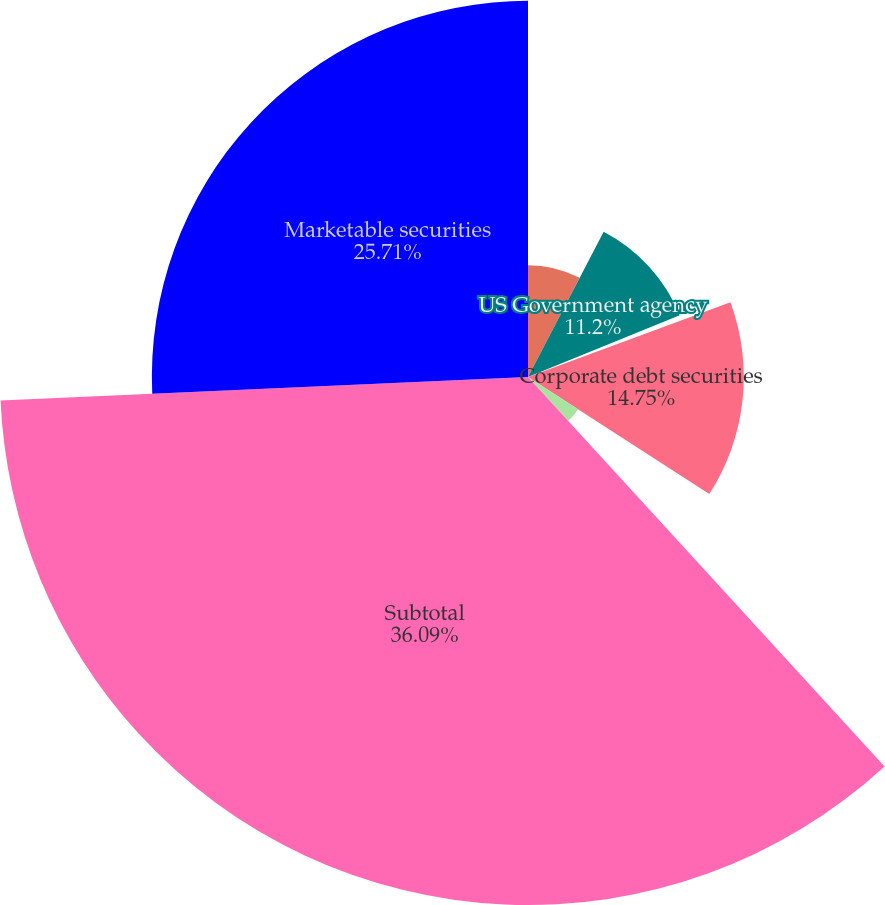Convert chart to OTSL. <chart><loc_0><loc_0><loc_500><loc_500><pie_chart><fcel>US Treasury securities<fcel>US Government agency<fcel>Municipal securities<fcel>Corporate debt securities<fcel>Sovereign securities<fcel>Subtotal<fcel>Marketable securities<nl><fcel>7.64%<fcel>11.2%<fcel>0.53%<fcel>14.75%<fcel>4.08%<fcel>36.09%<fcel>25.71%<nl></chart> 